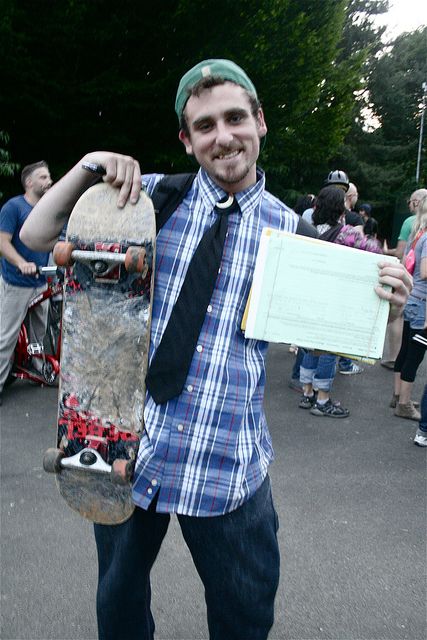<image>What continent is this picture likely from? It is ambiguous to determine the exact continent from the picture. It could likely be from North America or Europe. What continent is this picture likely from? It is ambiguous which continent this picture is likely from. It could be Europe or North America. 